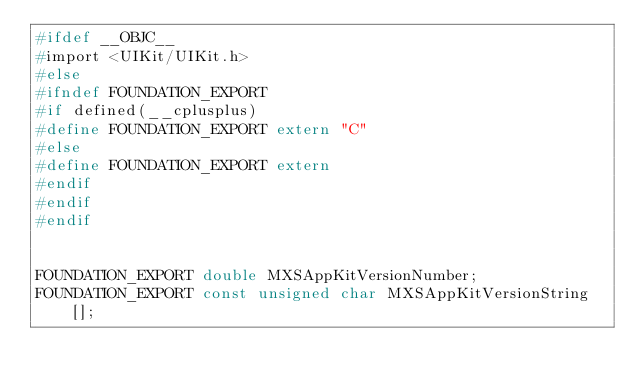Convert code to text. <code><loc_0><loc_0><loc_500><loc_500><_C_>#ifdef __OBJC__
#import <UIKit/UIKit.h>
#else
#ifndef FOUNDATION_EXPORT
#if defined(__cplusplus)
#define FOUNDATION_EXPORT extern "C"
#else
#define FOUNDATION_EXPORT extern
#endif
#endif
#endif


FOUNDATION_EXPORT double MXSAppKitVersionNumber;
FOUNDATION_EXPORT const unsigned char MXSAppKitVersionString[];

</code> 